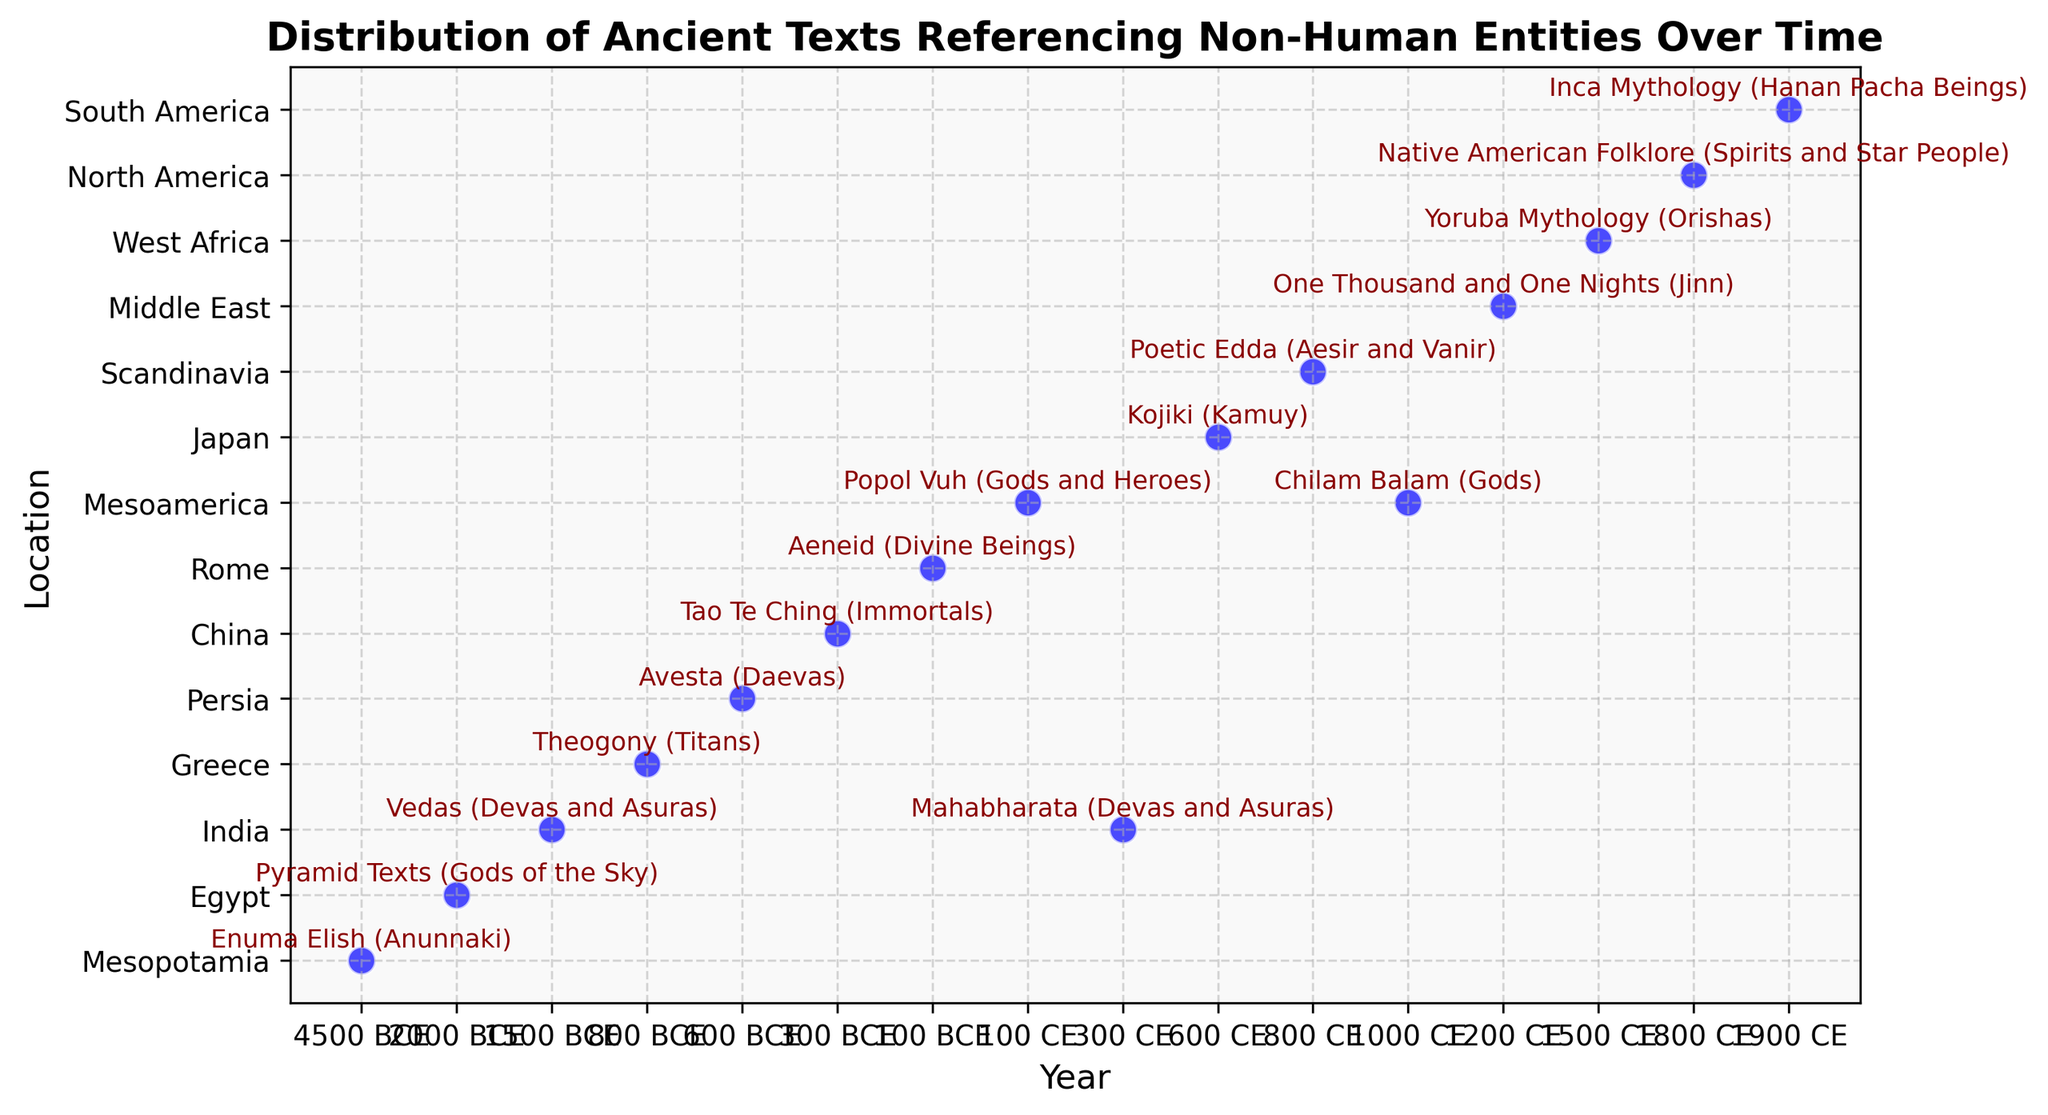How many texts reference non-human entities between 300 BCE and 300 CE? The date range from 300 BCE to 300 CE includes three data points: "Tao Te Ching" at 300 BCE, "Aeneid" at 100 BCE, and "Popol Vuh" at 100 CE.
Answer: 3 Which location has the earliest text referencing non-human entities, and what entity does it describe? The earliest text is from 4500 BCE in Mesopotamia, which is the "Enuma Elish" describing the Anunnaki.
Answer: Mesopotamia, Anunnaki How does the distribution of referenced texts change after 1000 CE? After 1000 CE, there are three referenced texts: "Chilam Balam" at 1000 CE, "One Thousand and One Nights" at 1200 CE, and "Yoruba Mythology" at 1500 CE, and "Native American Folklore" at 1800 CE., indicating a significant increase.
Answer: Increase What is the difference in years between the earliest and the latest texts in the dataset? The earliest text is from 4500 BCE, and the latest text is from 1900 CE. The difference in years is calculated as (4500 + 1900) = 6400 years.
Answer: 6400 years Identify two texts that were written in India and the non-human entities they describe. The two texts from India are the "Vedas" written in 1500 BCE describing Devas and Asuras, and the "Mahabharata" at 300 CE also describing Devas and Asuras.
Answer: Vedas (Devas and Asuras), Mahabharata (Devas and Asuras) Which text around 600 CE references non-human entities, and what location is it from? The text around 600 CE is the "Kojiki," referencing Kamuy, and it is from Japan.
Answer: Kojiki, Japan Which text and entity description are associated with the Middle East in the given data? The text associated with the Middle East in the data is "One Thousand and One Nights," and the entity described is Jinn.
Answer: One Thousand and One Nights, Jinn Compare the number of texts referencing non-human entities before and after 1 CE. Before 1 CE, there are seven texts: "Enuma Elish," "Pyramid Texts," "Vedas," "Theogony," "Avesta," "Tao Te Ching," and "Aeneid." After 1 CE, there are nine texts: "Popol Vuh," "Mahabharata," "Kojiki," "Poetic Edda," "Chilam Balam," "One Thousand and One Nights," "Yoruba Mythology," "Native American Folklore," "Inca Mythology." Therefore, there are more texts recorded after 1 CE.
Answer: More after 1 CE What visual trends can you observe about the spread of texts over geographic locations? Visually, it is apparent that references to non-human entities span a wide range of geographic locations from Mesopotamia to North America and across various time periods. This indicates a widespread cross-cultural pattern of referencing non-human entities.
Answer: Widespread across locations and time 